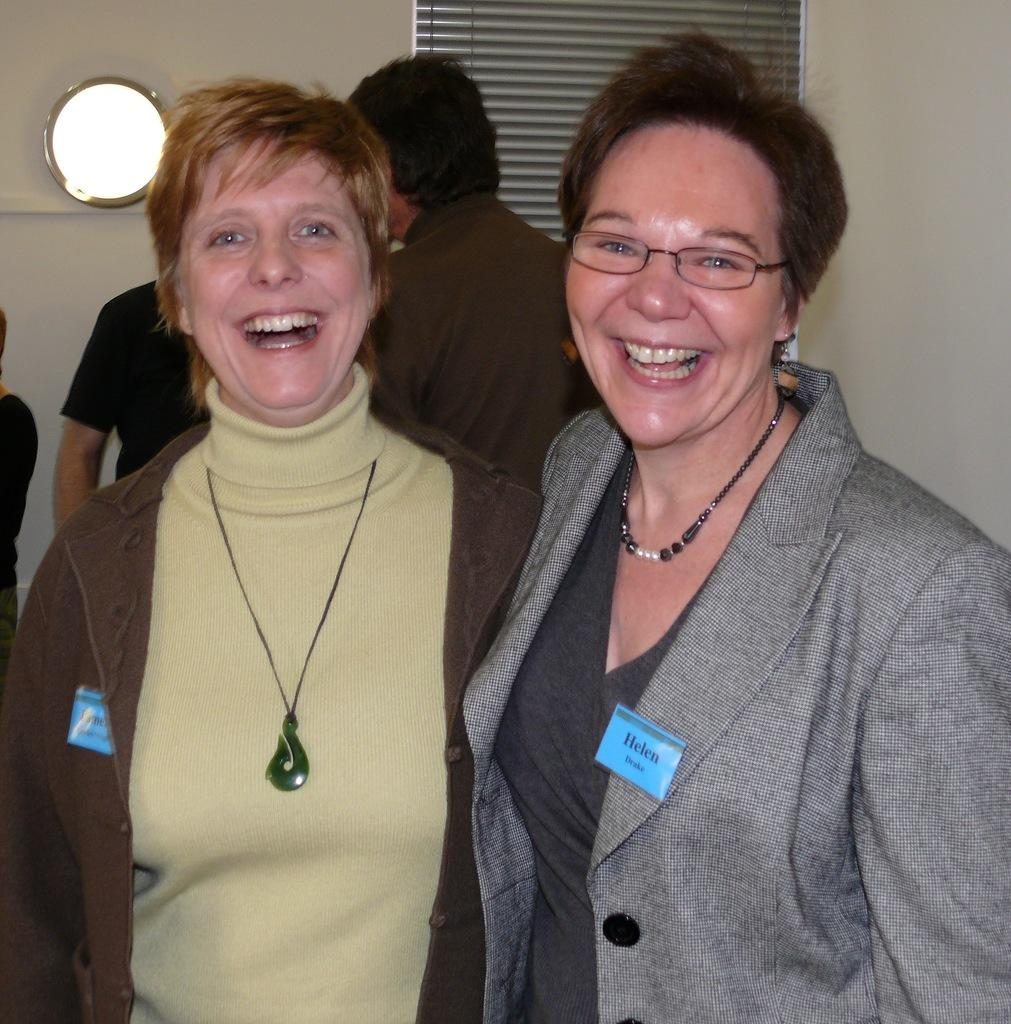What are the two main subjects in the image? Two ladies are standing in the center of the image. What are the ladies doing in the image? The ladies are laughing. Can you describe the background of the image? There are persons in the background of the image, as well as a mirror and a wall. What type of robin can be seen sitting on the boat in the image? There is no robin or boat present in the image. What shape is the square mirror in the image? There is no mention of a square mirror in the image; only a mirror is mentioned. 